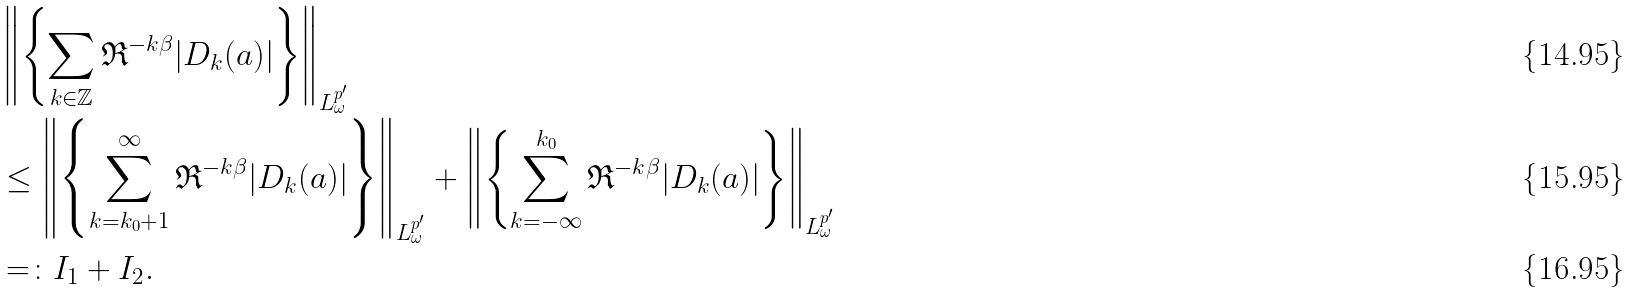<formula> <loc_0><loc_0><loc_500><loc_500>& \left \| \left \{ \sum _ { k \in \mathbb { Z } } { \mathfrak R } ^ { - k \beta } | D _ { k } ( a ) | \right \} \right \| _ { L ^ { p ^ { \prime } } _ { \omega } } \\ & \leq \left \| \left \{ \sum _ { k = k _ { 0 } + 1 } ^ { \infty } { \mathfrak R } ^ { - k \beta } | D _ { k } ( a ) | \right \} \right \| _ { L ^ { p ^ { \prime } } _ { \omega } } + \left \| \left \{ \sum _ { k = - \infty } ^ { k _ { 0 } } { \mathfrak R } ^ { - k \beta } | D _ { k } ( a ) | \right \} \right \| _ { L ^ { p ^ { \prime } } _ { \omega } } \\ & = \colon I _ { 1 } + I _ { 2 } .</formula> 